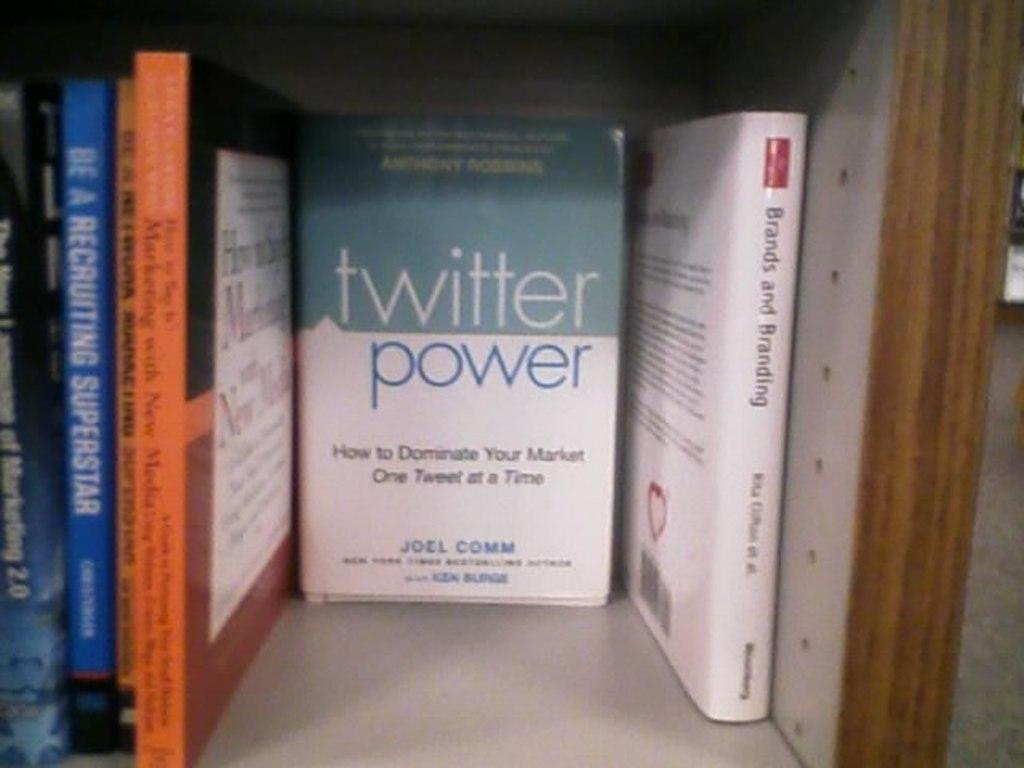<image>
Render a clear and concise summary of the photo. The book Twitter Power is facing with the cover out on a bookshelf in between other book bindings. 